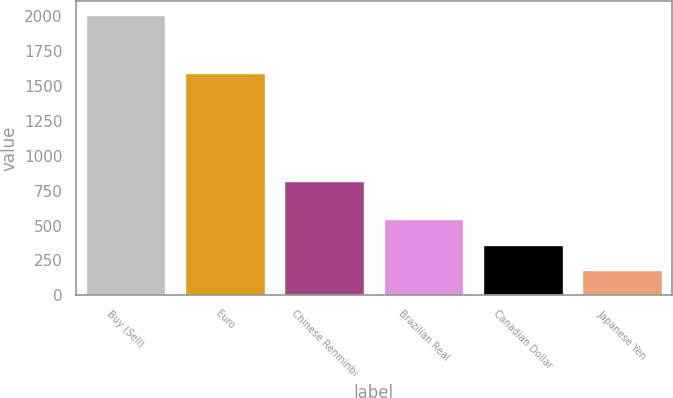Convert chart. <chart><loc_0><loc_0><loc_500><loc_500><bar_chart><fcel>Buy (Sell)<fcel>Euro<fcel>Chinese Renminbi<fcel>Brazilian Real<fcel>Canadian Dollar<fcel>Japanese Yen<nl><fcel>2004<fcel>1588<fcel>821<fcel>544<fcel>361.5<fcel>179<nl></chart> 